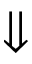Convert formula to latex. <formula><loc_0><loc_0><loc_500><loc_500>\Downarrow</formula> 